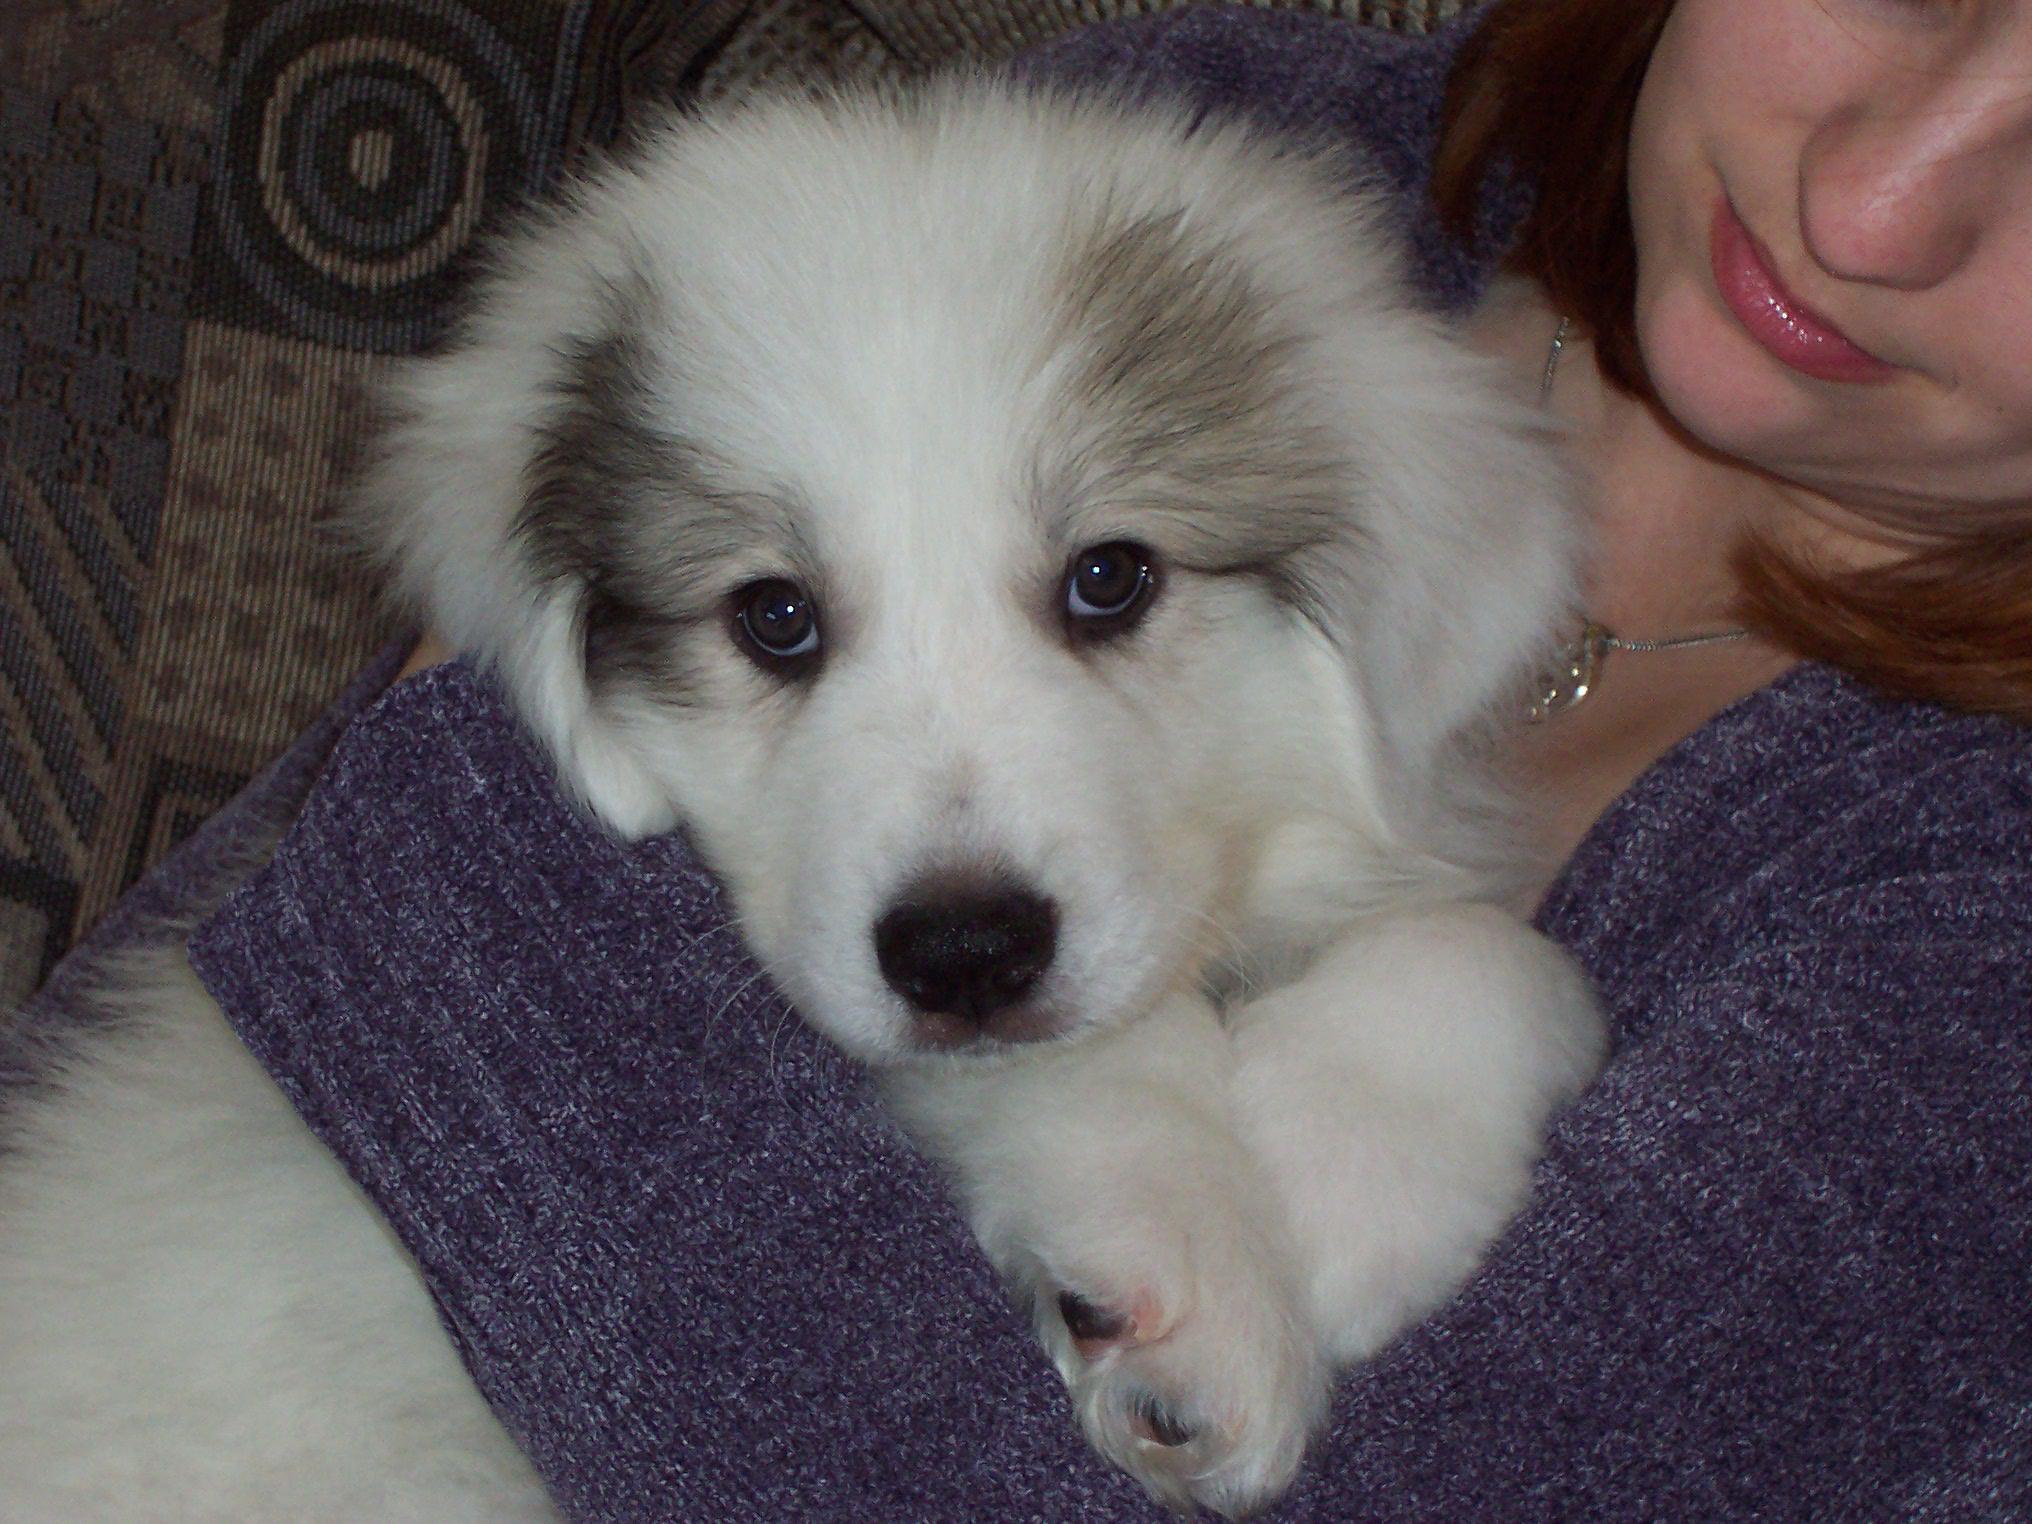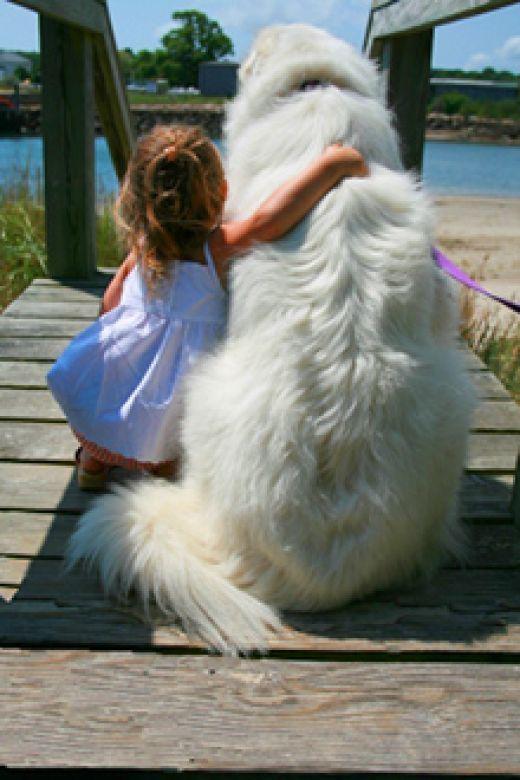The first image is the image on the left, the second image is the image on the right. Given the left and right images, does the statement "In one of the images there is a person holding a large white dog." hold true? Answer yes or no. Yes. 